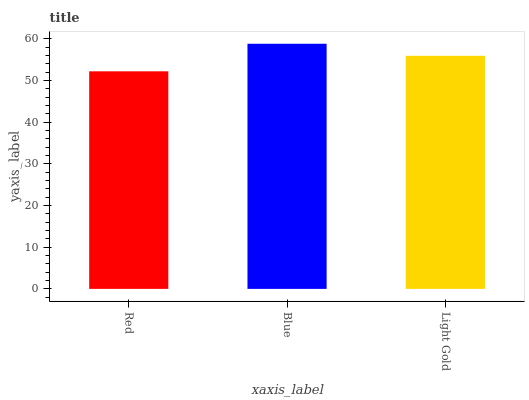Is Light Gold the minimum?
Answer yes or no. No. Is Light Gold the maximum?
Answer yes or no. No. Is Blue greater than Light Gold?
Answer yes or no. Yes. Is Light Gold less than Blue?
Answer yes or no. Yes. Is Light Gold greater than Blue?
Answer yes or no. No. Is Blue less than Light Gold?
Answer yes or no. No. Is Light Gold the high median?
Answer yes or no. Yes. Is Light Gold the low median?
Answer yes or no. Yes. Is Blue the high median?
Answer yes or no. No. Is Red the low median?
Answer yes or no. No. 